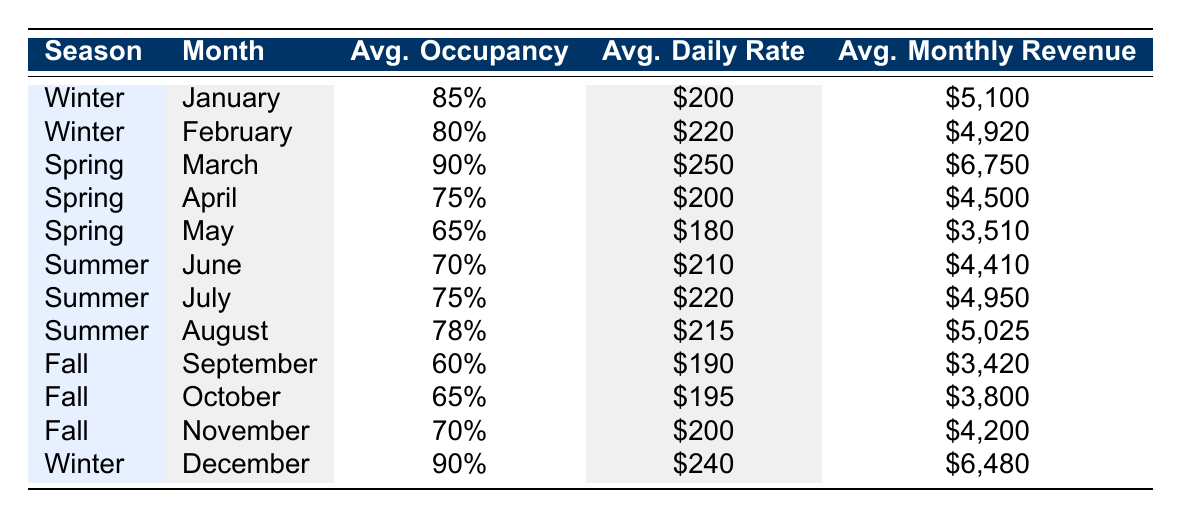What is the average daily rate for March? In the table, the row for March shows an "Average Daily Rate" of "$250".
Answer: $250 Which month has the highest average monthly revenue? By examining the "Average Monthly Revenue" column, March has "$6750," which is the highest figure among all the months listed.
Answer: March What is the average occupancy rate for the winter season? The three winter months are January (85%), February (80%), and December (90%). The average is calculated as (85 + 80 + 90) / 3 = 85%.
Answer: 85% Did the average daily rate increase from February to March? February's average daily rate is "$220," and March's is "$250." Since "$250" is greater than "$220," it confirms an increase.
Answer: Yes Which season has the lowest average occupancy rate? By looking at the occupancy rates for each season: Winter (85%, 80%, 90%), Spring (90%, 75%, 65%), Summer (70%, 75%, 78%), and Fall (60%, 65%, 70%), the average for Fall is the lowest at 65%.
Answer: Fall What is the sum of average monthly revenues for the summer months? The summer months' revenues are June ($4410), July ($4950), and August ($5025). The total sum is calculated as 4410 + 4950 + 5025 = 14385.
Answer: $14385 Is the average daily rate in April lower than that in May? April's average daily rate is "$200," and May's is "$180." Since "$200" is greater than "$180," the statement is false.
Answer: No What is the median average occupancy rate across all months? The occupancy rates are: 85%, 80%, 90%, 90%, 75%, 65%, 70%, 75%, 78%, 60%, 65%, and 70%. When organized in ascending order (60%, 65%, 65%, 70%, 70%, 75%, 75%, 78%, 80%, 85%, 90%, 90%), the median is the average of the 6th and 7th values, which is (75+75)/2 = 75%.
Answer: 75% 